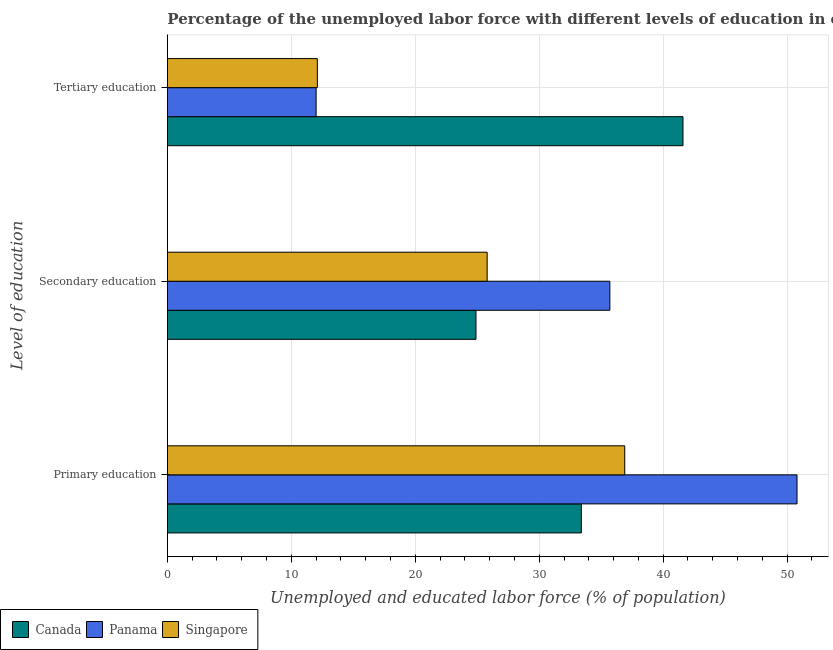How many bars are there on the 1st tick from the top?
Keep it short and to the point. 3. What is the label of the 2nd group of bars from the top?
Your answer should be very brief. Secondary education. What is the percentage of labor force who received primary education in Singapore?
Keep it short and to the point. 36.9. Across all countries, what is the maximum percentage of labor force who received tertiary education?
Ensure brevity in your answer.  41.6. Across all countries, what is the minimum percentage of labor force who received tertiary education?
Offer a very short reply. 12. In which country was the percentage of labor force who received primary education maximum?
Provide a short and direct response. Panama. In which country was the percentage of labor force who received primary education minimum?
Keep it short and to the point. Canada. What is the total percentage of labor force who received primary education in the graph?
Keep it short and to the point. 121.1. What is the difference between the percentage of labor force who received tertiary education in Singapore and that in Canada?
Ensure brevity in your answer.  -29.5. What is the difference between the percentage of labor force who received tertiary education in Panama and the percentage of labor force who received secondary education in Canada?
Your answer should be very brief. -12.9. What is the average percentage of labor force who received primary education per country?
Offer a terse response. 40.37. What is the difference between the percentage of labor force who received tertiary education and percentage of labor force who received secondary education in Panama?
Give a very brief answer. -23.7. In how many countries, is the percentage of labor force who received primary education greater than 30 %?
Provide a short and direct response. 3. What is the ratio of the percentage of labor force who received tertiary education in Panama to that in Canada?
Make the answer very short. 0.29. Is the percentage of labor force who received tertiary education in Panama less than that in Singapore?
Give a very brief answer. Yes. What is the difference between the highest and the second highest percentage of labor force who received tertiary education?
Make the answer very short. 29.5. What is the difference between the highest and the lowest percentage of labor force who received primary education?
Make the answer very short. 17.4. In how many countries, is the percentage of labor force who received secondary education greater than the average percentage of labor force who received secondary education taken over all countries?
Provide a succinct answer. 1. Is the sum of the percentage of labor force who received primary education in Singapore and Canada greater than the maximum percentage of labor force who received secondary education across all countries?
Offer a terse response. Yes. What does the 2nd bar from the bottom in Primary education represents?
Your answer should be very brief. Panama. How many bars are there?
Offer a terse response. 9. Are the values on the major ticks of X-axis written in scientific E-notation?
Provide a succinct answer. No. Does the graph contain grids?
Your response must be concise. Yes. How many legend labels are there?
Ensure brevity in your answer.  3. How are the legend labels stacked?
Keep it short and to the point. Horizontal. What is the title of the graph?
Provide a short and direct response. Percentage of the unemployed labor force with different levels of education in countries. What is the label or title of the X-axis?
Ensure brevity in your answer.  Unemployed and educated labor force (% of population). What is the label or title of the Y-axis?
Provide a short and direct response. Level of education. What is the Unemployed and educated labor force (% of population) of Canada in Primary education?
Give a very brief answer. 33.4. What is the Unemployed and educated labor force (% of population) in Panama in Primary education?
Make the answer very short. 50.8. What is the Unemployed and educated labor force (% of population) in Singapore in Primary education?
Offer a terse response. 36.9. What is the Unemployed and educated labor force (% of population) in Canada in Secondary education?
Ensure brevity in your answer.  24.9. What is the Unemployed and educated labor force (% of population) in Panama in Secondary education?
Offer a terse response. 35.7. What is the Unemployed and educated labor force (% of population) in Singapore in Secondary education?
Make the answer very short. 25.8. What is the Unemployed and educated labor force (% of population) of Canada in Tertiary education?
Give a very brief answer. 41.6. What is the Unemployed and educated labor force (% of population) of Singapore in Tertiary education?
Ensure brevity in your answer.  12.1. Across all Level of education, what is the maximum Unemployed and educated labor force (% of population) in Canada?
Your response must be concise. 41.6. Across all Level of education, what is the maximum Unemployed and educated labor force (% of population) in Panama?
Ensure brevity in your answer.  50.8. Across all Level of education, what is the maximum Unemployed and educated labor force (% of population) in Singapore?
Offer a very short reply. 36.9. Across all Level of education, what is the minimum Unemployed and educated labor force (% of population) in Canada?
Offer a terse response. 24.9. Across all Level of education, what is the minimum Unemployed and educated labor force (% of population) in Panama?
Ensure brevity in your answer.  12. Across all Level of education, what is the minimum Unemployed and educated labor force (% of population) in Singapore?
Your response must be concise. 12.1. What is the total Unemployed and educated labor force (% of population) of Canada in the graph?
Your response must be concise. 99.9. What is the total Unemployed and educated labor force (% of population) in Panama in the graph?
Offer a very short reply. 98.5. What is the total Unemployed and educated labor force (% of population) of Singapore in the graph?
Offer a very short reply. 74.8. What is the difference between the Unemployed and educated labor force (% of population) in Canada in Primary education and that in Tertiary education?
Offer a very short reply. -8.2. What is the difference between the Unemployed and educated labor force (% of population) of Panama in Primary education and that in Tertiary education?
Provide a succinct answer. 38.8. What is the difference between the Unemployed and educated labor force (% of population) in Singapore in Primary education and that in Tertiary education?
Your response must be concise. 24.8. What is the difference between the Unemployed and educated labor force (% of population) in Canada in Secondary education and that in Tertiary education?
Offer a very short reply. -16.7. What is the difference between the Unemployed and educated labor force (% of population) of Panama in Secondary education and that in Tertiary education?
Offer a very short reply. 23.7. What is the difference between the Unemployed and educated labor force (% of population) of Singapore in Secondary education and that in Tertiary education?
Make the answer very short. 13.7. What is the difference between the Unemployed and educated labor force (% of population) in Canada in Primary education and the Unemployed and educated labor force (% of population) in Panama in Secondary education?
Make the answer very short. -2.3. What is the difference between the Unemployed and educated labor force (% of population) in Panama in Primary education and the Unemployed and educated labor force (% of population) in Singapore in Secondary education?
Provide a short and direct response. 25. What is the difference between the Unemployed and educated labor force (% of population) of Canada in Primary education and the Unemployed and educated labor force (% of population) of Panama in Tertiary education?
Provide a short and direct response. 21.4. What is the difference between the Unemployed and educated labor force (% of population) in Canada in Primary education and the Unemployed and educated labor force (% of population) in Singapore in Tertiary education?
Your response must be concise. 21.3. What is the difference between the Unemployed and educated labor force (% of population) in Panama in Primary education and the Unemployed and educated labor force (% of population) in Singapore in Tertiary education?
Your answer should be very brief. 38.7. What is the difference between the Unemployed and educated labor force (% of population) in Canada in Secondary education and the Unemployed and educated labor force (% of population) in Panama in Tertiary education?
Ensure brevity in your answer.  12.9. What is the difference between the Unemployed and educated labor force (% of population) in Canada in Secondary education and the Unemployed and educated labor force (% of population) in Singapore in Tertiary education?
Your response must be concise. 12.8. What is the difference between the Unemployed and educated labor force (% of population) of Panama in Secondary education and the Unemployed and educated labor force (% of population) of Singapore in Tertiary education?
Your response must be concise. 23.6. What is the average Unemployed and educated labor force (% of population) of Canada per Level of education?
Offer a very short reply. 33.3. What is the average Unemployed and educated labor force (% of population) in Panama per Level of education?
Ensure brevity in your answer.  32.83. What is the average Unemployed and educated labor force (% of population) in Singapore per Level of education?
Offer a very short reply. 24.93. What is the difference between the Unemployed and educated labor force (% of population) of Canada and Unemployed and educated labor force (% of population) of Panama in Primary education?
Your response must be concise. -17.4. What is the difference between the Unemployed and educated labor force (% of population) in Canada and Unemployed and educated labor force (% of population) in Singapore in Primary education?
Make the answer very short. -3.5. What is the difference between the Unemployed and educated labor force (% of population) in Panama and Unemployed and educated labor force (% of population) in Singapore in Primary education?
Your response must be concise. 13.9. What is the difference between the Unemployed and educated labor force (% of population) in Canada and Unemployed and educated labor force (% of population) in Singapore in Secondary education?
Make the answer very short. -0.9. What is the difference between the Unemployed and educated labor force (% of population) in Panama and Unemployed and educated labor force (% of population) in Singapore in Secondary education?
Make the answer very short. 9.9. What is the difference between the Unemployed and educated labor force (% of population) of Canada and Unemployed and educated labor force (% of population) of Panama in Tertiary education?
Provide a short and direct response. 29.6. What is the difference between the Unemployed and educated labor force (% of population) of Canada and Unemployed and educated labor force (% of population) of Singapore in Tertiary education?
Your answer should be compact. 29.5. What is the ratio of the Unemployed and educated labor force (% of population) of Canada in Primary education to that in Secondary education?
Offer a terse response. 1.34. What is the ratio of the Unemployed and educated labor force (% of population) of Panama in Primary education to that in Secondary education?
Offer a very short reply. 1.42. What is the ratio of the Unemployed and educated labor force (% of population) in Singapore in Primary education to that in Secondary education?
Keep it short and to the point. 1.43. What is the ratio of the Unemployed and educated labor force (% of population) in Canada in Primary education to that in Tertiary education?
Your answer should be very brief. 0.8. What is the ratio of the Unemployed and educated labor force (% of population) in Panama in Primary education to that in Tertiary education?
Offer a very short reply. 4.23. What is the ratio of the Unemployed and educated labor force (% of population) in Singapore in Primary education to that in Tertiary education?
Provide a short and direct response. 3.05. What is the ratio of the Unemployed and educated labor force (% of population) of Canada in Secondary education to that in Tertiary education?
Offer a terse response. 0.6. What is the ratio of the Unemployed and educated labor force (% of population) in Panama in Secondary education to that in Tertiary education?
Your answer should be compact. 2.98. What is the ratio of the Unemployed and educated labor force (% of population) in Singapore in Secondary education to that in Tertiary education?
Your answer should be compact. 2.13. What is the difference between the highest and the second highest Unemployed and educated labor force (% of population) in Panama?
Your answer should be compact. 15.1. What is the difference between the highest and the lowest Unemployed and educated labor force (% of population) of Canada?
Ensure brevity in your answer.  16.7. What is the difference between the highest and the lowest Unemployed and educated labor force (% of population) in Panama?
Your answer should be very brief. 38.8. What is the difference between the highest and the lowest Unemployed and educated labor force (% of population) in Singapore?
Your answer should be compact. 24.8. 